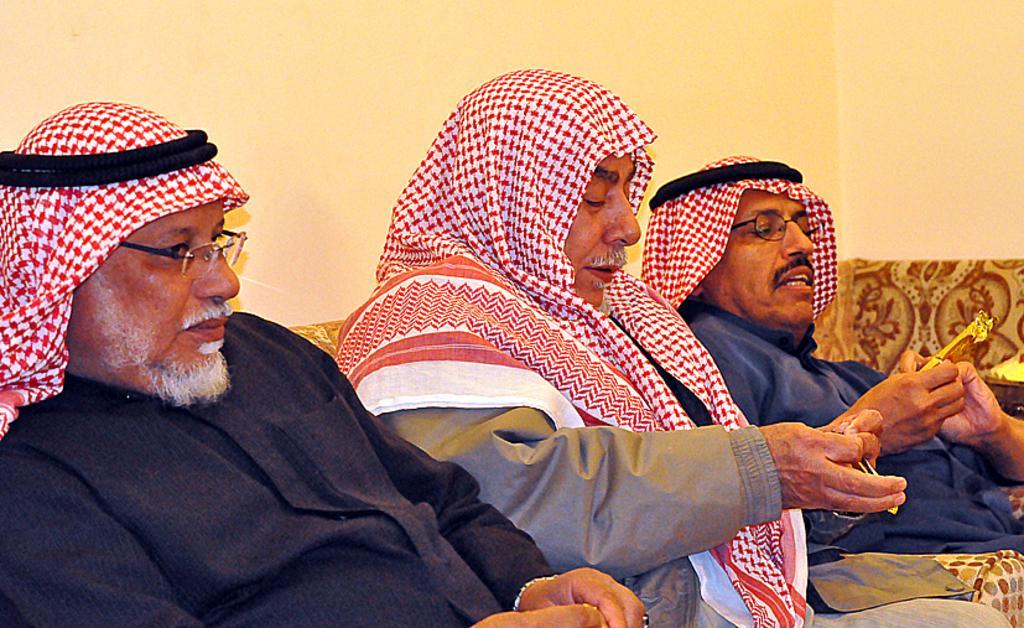In one or two sentences, can you explain what this image depicts? In the foreground of the picture there are three men sitting in a couch. In the background it is well. 